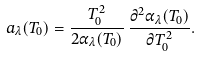<formula> <loc_0><loc_0><loc_500><loc_500>a _ { \lambda } ( T _ { 0 } ) = \frac { T _ { 0 } ^ { 2 } } { 2 \alpha _ { \lambda } ( T _ { 0 } ) } \, \frac { \partial ^ { 2 } \alpha _ { \lambda } ( T _ { 0 } ) } { \partial T _ { 0 } ^ { 2 } } .</formula> 